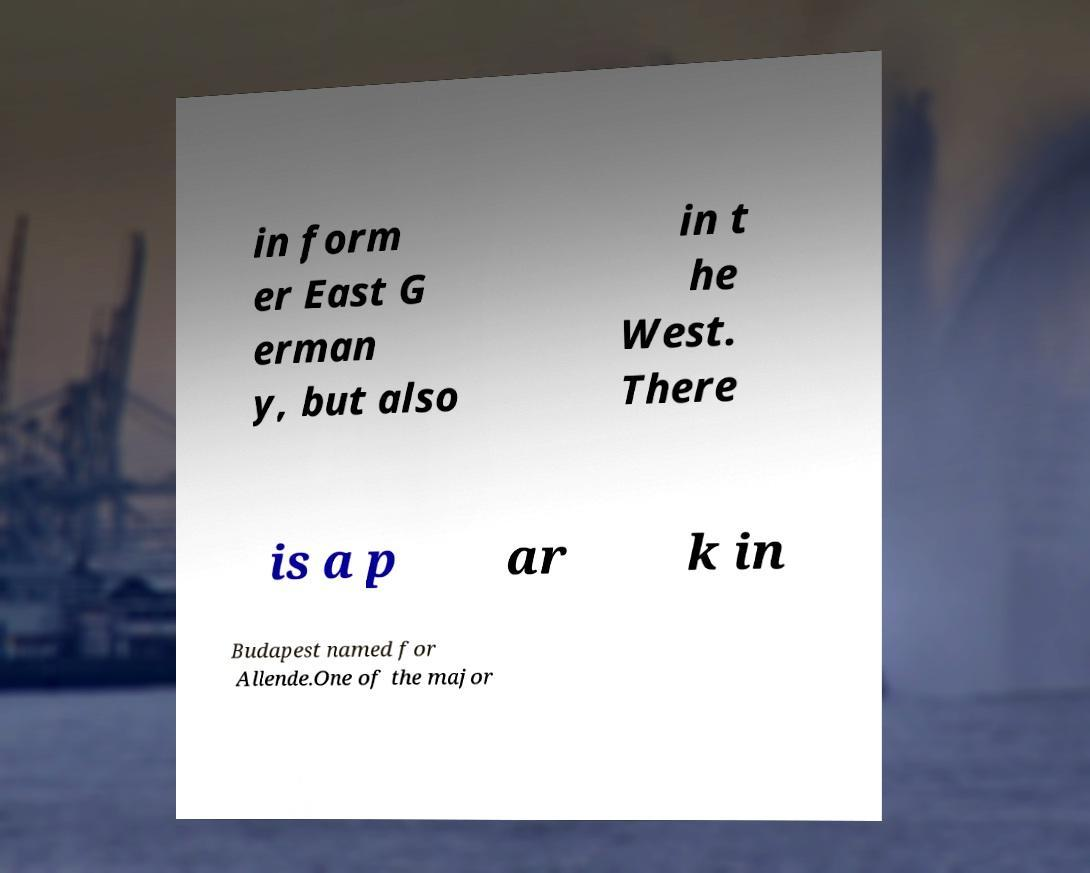Please read and relay the text visible in this image. What does it say? in form er East G erman y, but also in t he West. There is a p ar k in Budapest named for Allende.One of the major 